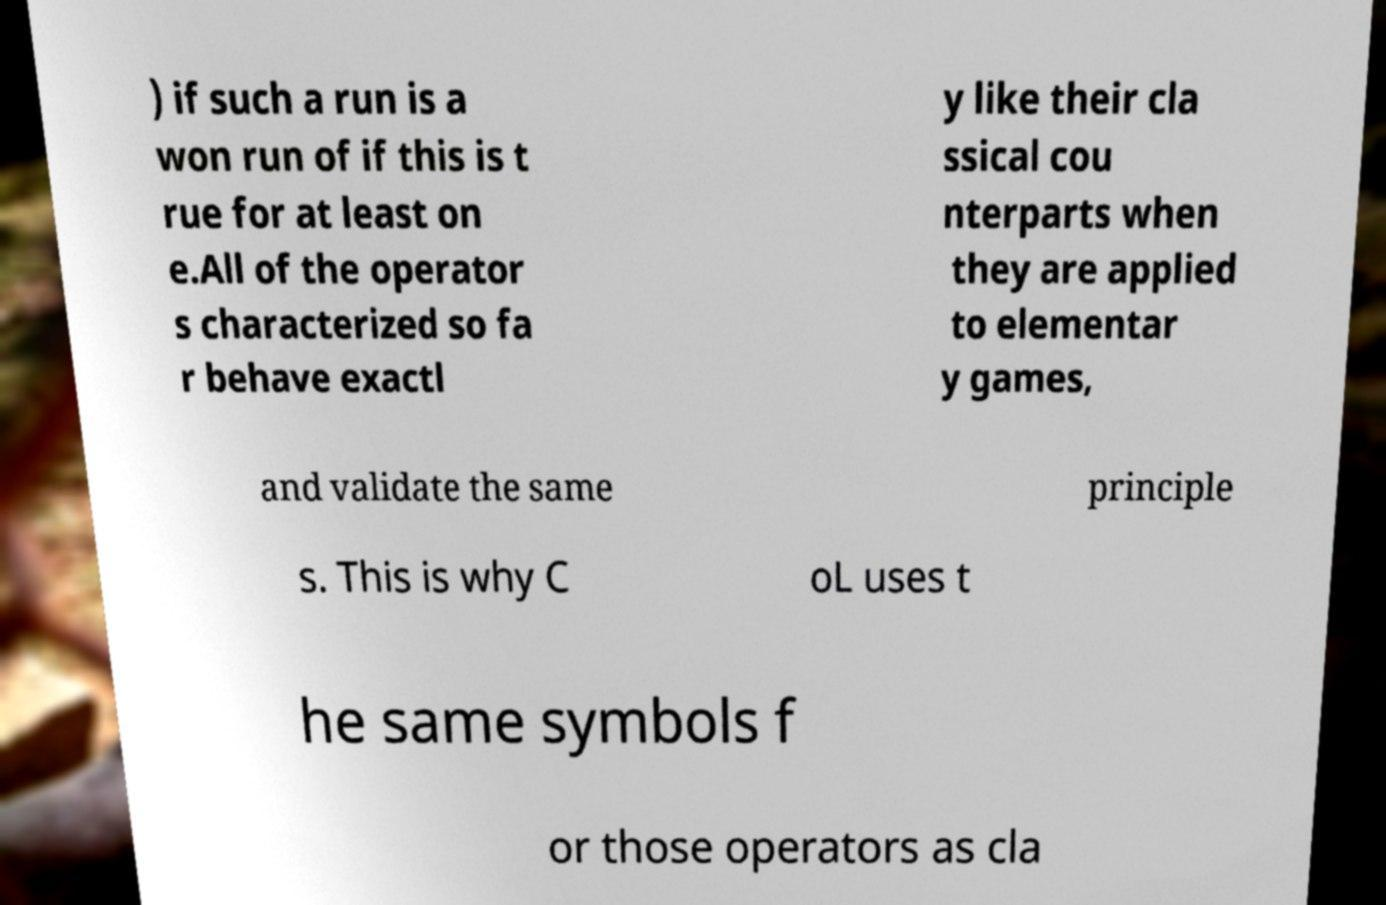There's text embedded in this image that I need extracted. Can you transcribe it verbatim? ) if such a run is a won run of if this is t rue for at least on e.All of the operator s characterized so fa r behave exactl y like their cla ssical cou nterparts when they are applied to elementar y games, and validate the same principle s. This is why C oL uses t he same symbols f or those operators as cla 